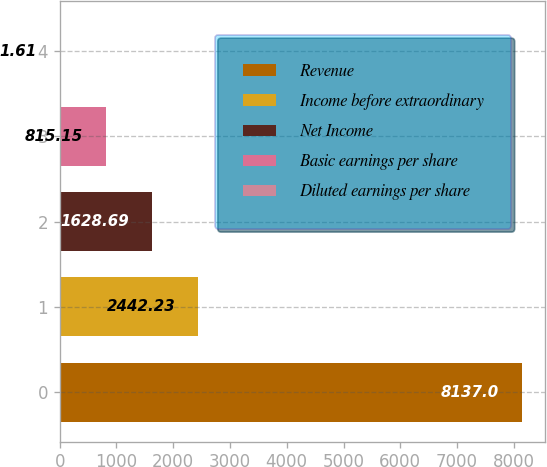<chart> <loc_0><loc_0><loc_500><loc_500><bar_chart><fcel>Revenue<fcel>Income before extraordinary<fcel>Net Income<fcel>Basic earnings per share<fcel>Diluted earnings per share<nl><fcel>8137<fcel>2442.23<fcel>1628.69<fcel>815.15<fcel>1.61<nl></chart> 